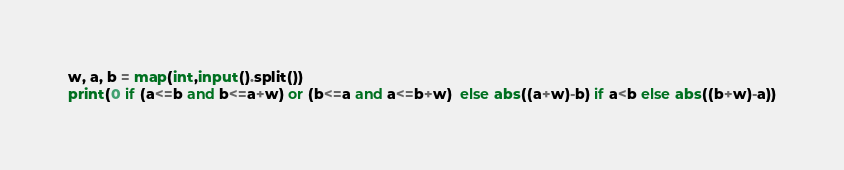Convert code to text. <code><loc_0><loc_0><loc_500><loc_500><_Python_>w, a, b = map(int,input().split())
print(0 if (a<=b and b<=a+w) or (b<=a and a<=b+w)  else abs((a+w)-b) if a<b else abs((b+w)-a))
</code> 